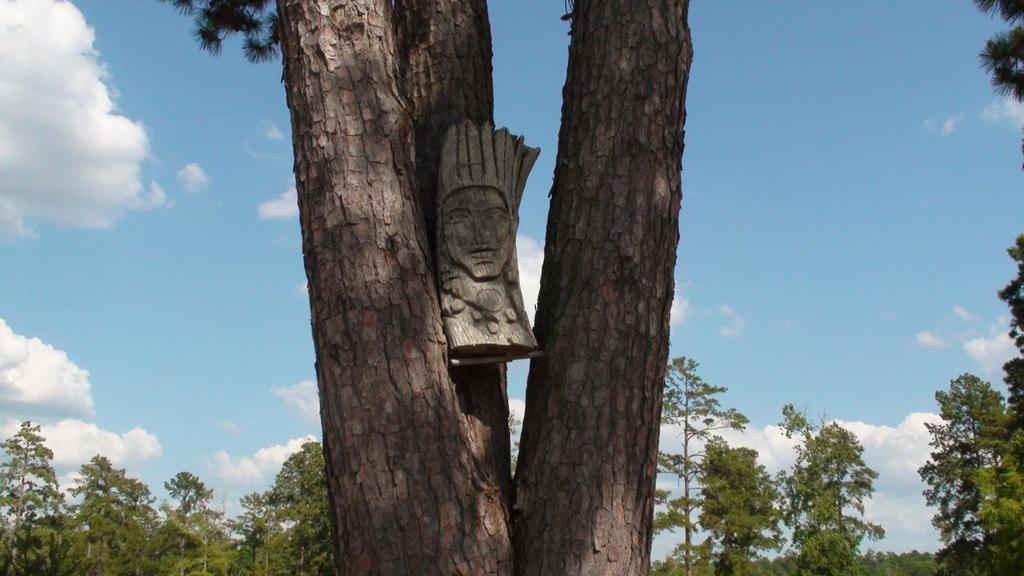What is located in the front of the image? There is a tree trunk and a wooden mask in the front of the image. What can be seen in the background of the image? There are trees in the background of the image. How would you describe the sky in the image? The sky is cloudy in the image. Where is the house located in the image? There is no house present in the image. What type of pail is being used to collect water from the pump in the image? There is no pail or pump present in the image. 